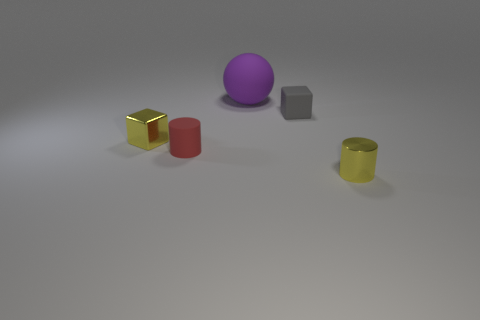The tiny matte cylinder has what color?
Provide a succinct answer. Red. There is another small thing that is the same shape as the gray thing; what material is it?
Ensure brevity in your answer.  Metal. Are there any other things that have the same material as the large purple thing?
Your response must be concise. Yes. Is the color of the big matte sphere the same as the tiny metal cube?
Your answer should be very brief. No. There is a small rubber object in front of the cube that is left of the large matte object; what shape is it?
Your response must be concise. Cylinder. There is a large object that is the same material as the tiny red thing; what shape is it?
Ensure brevity in your answer.  Sphere. How many other things are there of the same shape as the purple thing?
Your answer should be compact. 0. There is a object that is to the left of the red rubber cylinder; is it the same size as the big rubber object?
Provide a succinct answer. No. Are there more purple spheres that are in front of the tiny red rubber object than small gray matte blocks?
Keep it short and to the point. No. There is a yellow thing that is on the left side of the big object; what number of small metallic objects are in front of it?
Your answer should be compact. 1. 